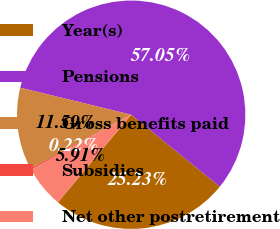Convert chart. <chart><loc_0><loc_0><loc_500><loc_500><pie_chart><fcel>Year(s)<fcel>Pensions<fcel>Gross benefits paid<fcel>Subsidies<fcel>Net other postretirement<nl><fcel>25.23%<fcel>57.05%<fcel>11.59%<fcel>0.22%<fcel>5.91%<nl></chart> 